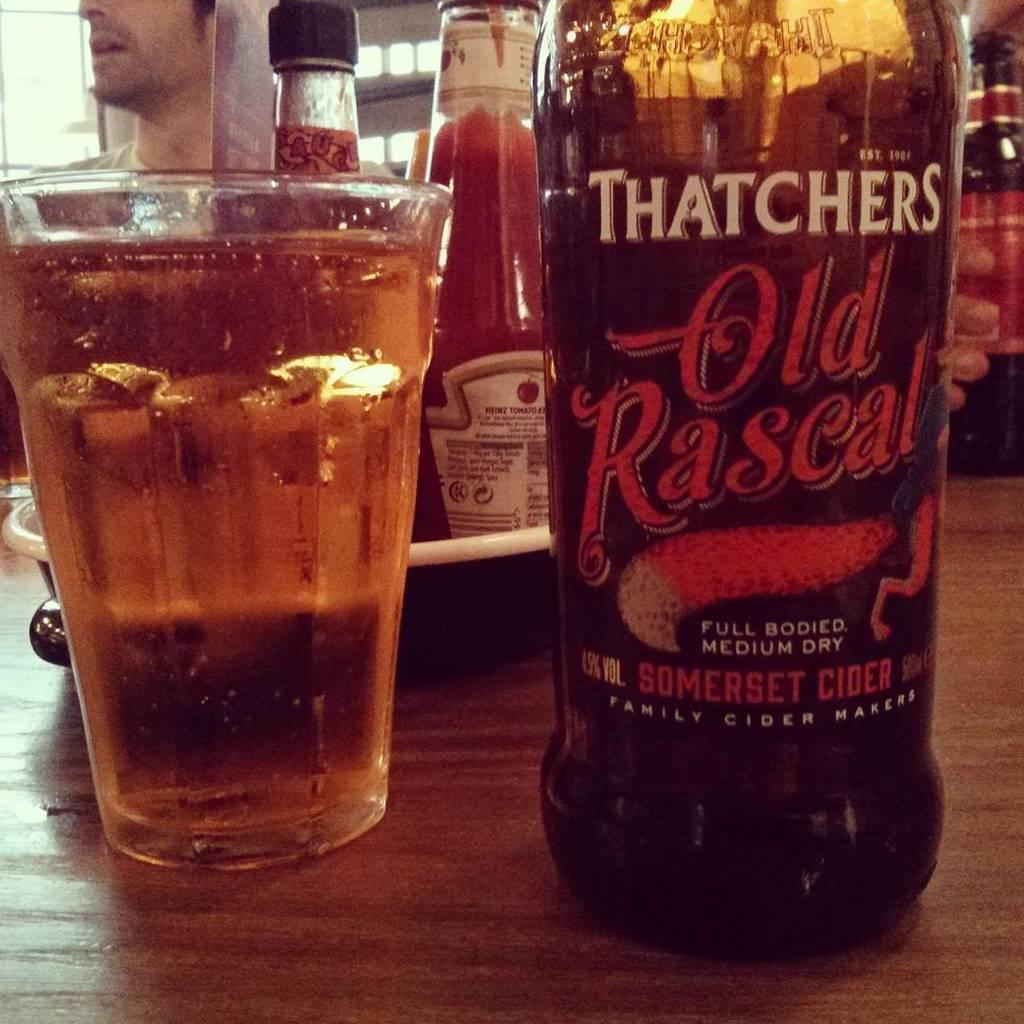<image>
Summarize the visual content of the image. a close up of a Thatchers Old Rascal bottle next to a full glass 